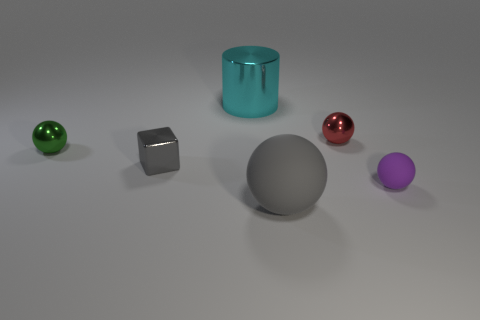Subtract all red metallic spheres. How many spheres are left? 3 Add 3 big cyan matte blocks. How many objects exist? 9 Subtract all gray spheres. How many spheres are left? 3 Subtract all purple cylinders. Subtract all cyan cubes. How many cylinders are left? 1 Subtract all cyan blocks. How many purple balls are left? 1 Subtract all gray balls. Subtract all gray matte things. How many objects are left? 4 Add 5 gray balls. How many gray balls are left? 6 Add 4 big gray balls. How many big gray balls exist? 5 Subtract 0 cyan spheres. How many objects are left? 6 Subtract all cubes. How many objects are left? 5 